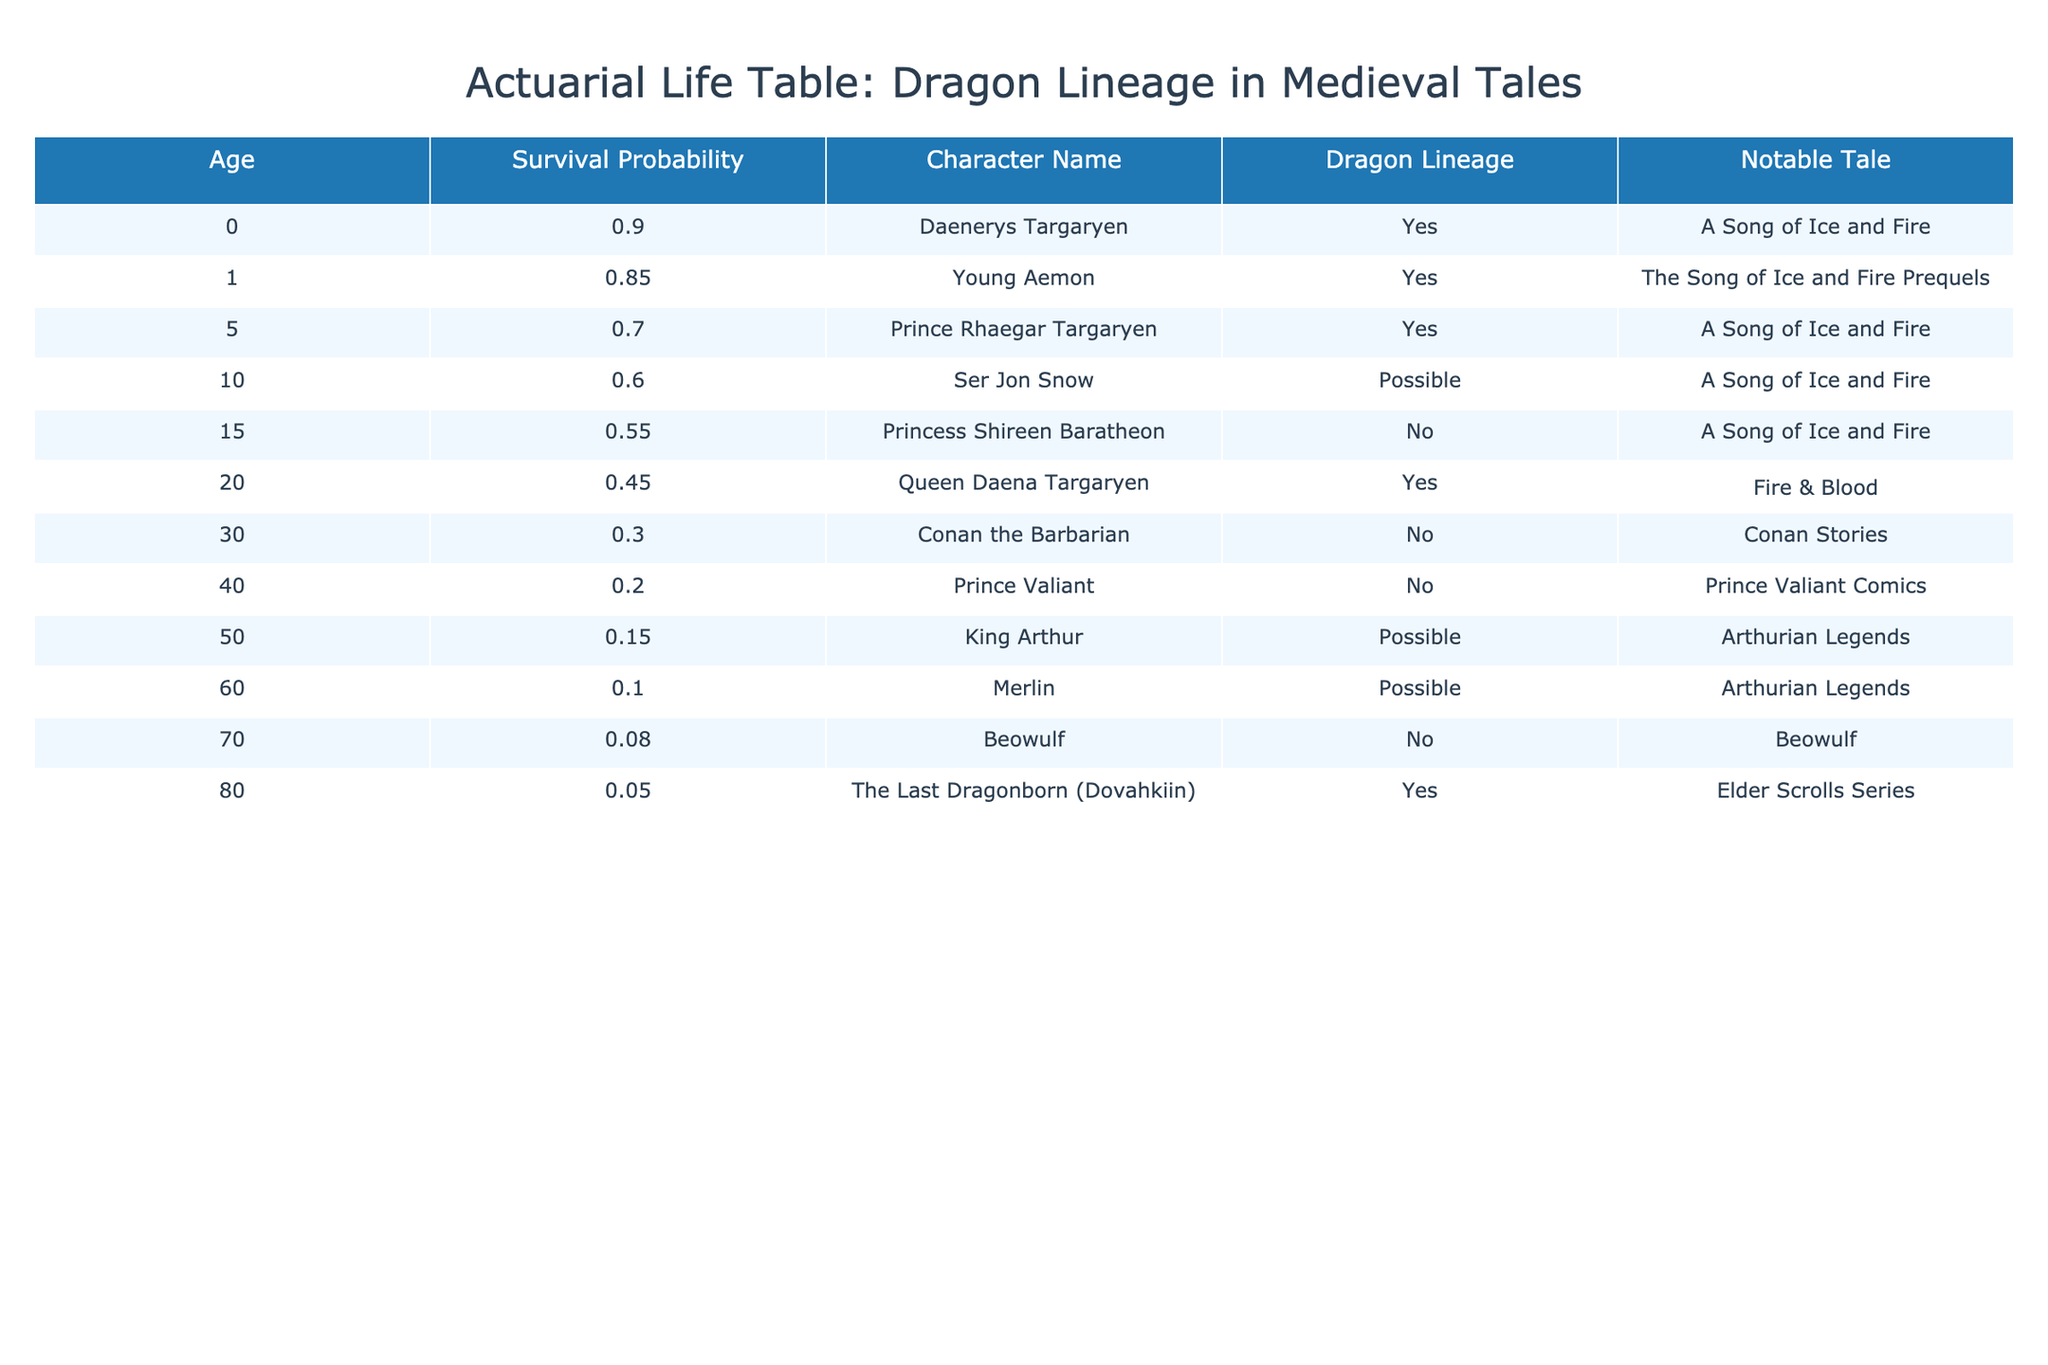What is the survival probability of Daenerys Targaryen at age 0? The table shows the survival probability for each character at age 0. For Daenerys Targaryen, it lists a survival probability of 0.90 directly.
Answer: 0.90 Which character has the lowest survival probability, and what is it? By looking through the table, the character with the lowest survival probability is The Last Dragonborn (Dovahkiin) at age 80, with a probability of 0.05.
Answer: The Last Dragonborn (Dovahkiin), 0.05 Are there any characters in the table that have dragon lineage but have a survival probability below 0.30? Checking the table, the characters with dragon lineage are Daenerys Targaryen, Young Aemon, Prince Rhaegar Targaryen, Queen Daena Targaryen, and The Last Dragonborn (Dovahkiin). Among them, Queen Daena Targaryen at age 20 has a survival probability of 0.45, and The Last Dragonborn at age 80 has a probability of 0.05. Therefore, The Last Dragonborn is the only character with dragon lineage below 0.30.
Answer: Yes, The Last Dragonborn (Dovahkiin) What is the average survival probability of characters aged 0, 1, and 5? The survival probabilities for those ages are: 0.90 (Age 0), 0.85 (Age 1), and 0.70 (Age 5). To find the average, we sum these probabilities, 0.90 + 0.85 + 0.70 = 2.45, and divide by the number of values (3), resulting in 2.45 / 3 = 0.8167.
Answer: 0.82 Is there any character without dragon lineage that has a survival probability of 0.15 or higher? The characters without dragon lineage include Princess Shireen Baratheon, Conan the Barbarian, and Prince Valiant. Their survival probabilities are 0.55, 0.30, and 0.20 respectively. Since 0.55 > 0.15, Princess Shireen Baratheon is the character without dragon lineage that meets the criteria.
Answer: Yes, Princess Shireen Baratheon What is the combined survival probability of all characters aged 40 and above? The survival probabilities for characters aged 40 and above are 0.20 (Prince Valiant at 40), 0.15 (King Arthur at 50), 0.10 (Merlin at 60), 0.08 (Beowulf at 70), and 0.05 (The Last Dragonborn at 80). Summing these, we get 0.20 + 0.15 + 0.10 + 0.08 + 0.05 = 0.58.
Answer: 0.58 How many characters have a survival probability of 0.60 or higher? By reviewing the table, those with a survival probability of 0.60 or higher are Daenerys Targaryen (0.90), Young Aemon (0.85), and Prince Rhaegar Targaryen (0.70). Thus, there are three characters who meet this criterion.
Answer: 3 What is the change in survival probability for the character with dragon lineage from age 0 to age 20? Daenerys Targaryen starts with a survival probability of 0.90 at age 0 and has a probability of 0.45 at age 20 (Queen Daena Targaryen, also dragon lineage). The change is calculated as 0.90 - 0.45 = 0.45.
Answer: 0.45 